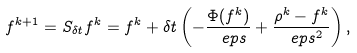<formula> <loc_0><loc_0><loc_500><loc_500>f ^ { k + 1 } = S _ { \delta t } f ^ { k } = f ^ { k } + \delta t \left ( - \frac { \Phi ( f ^ { k } ) } { \ e p s } + \frac { \rho ^ { k } - f ^ { k } } { \ e p s ^ { 2 } } \right ) ,</formula> 